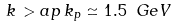Convert formula to latex. <formula><loc_0><loc_0><loc_500><loc_500>k \, > a p \, k _ { p } \simeq 1 . 5 \ G e V</formula> 